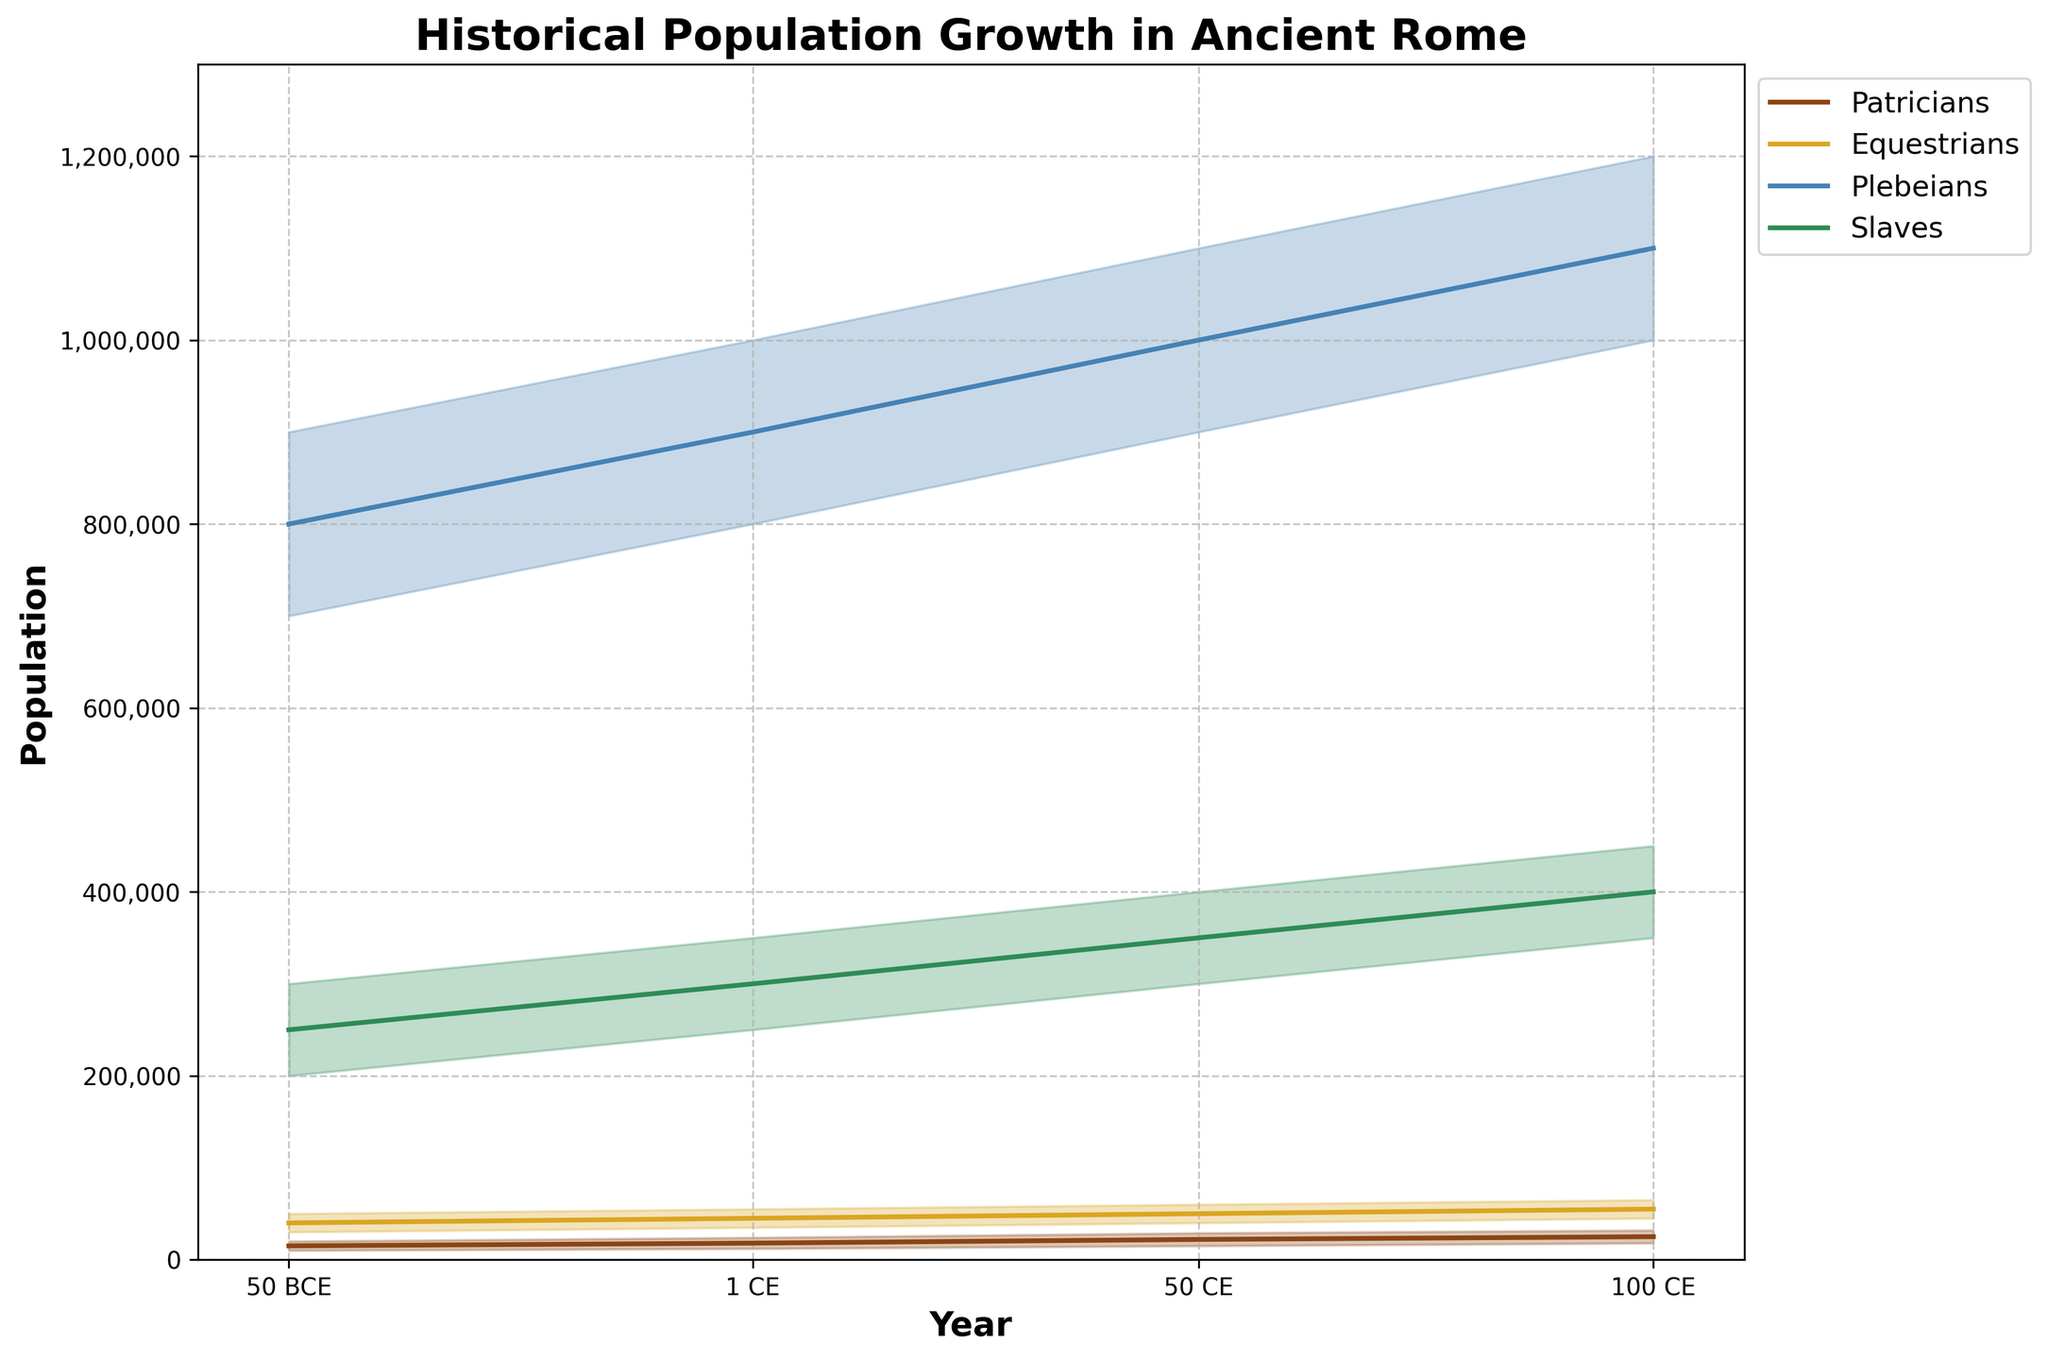What is the title of the chart? The title is located at the top of the chart. It reads "Historical Population Growth in Ancient Rome".
Answer: Historical Population Growth in Ancient Rome What does the x-axis represent? The x-axis is labelled "Year" and includes four points: 50 BCE, 1 CE, 50 CE, and 100 CE.
Answer: Year What does the y-axis represent? The y-axis is labelled "Population" and shows the number of people in each class over time.
Answer: Population Which social class had the largest population in 50 BCE? By comparing the plotted lines and shaded areas for all classes in 50 BCE, the Plebeians had the largest median population, with around 800,000 people.
Answer: Plebeians What was the median population of the Equestrians in 1 CE? By referring to the Equestrians' line plot at the year 1 CE, located slightly to the right of the middle, the median population is approximately 45,000.
Answer: 45,000 By how much did the median population of Patricians increase from 50 BCE to 100 CE? Look at the Patricians' median line in both 50 BCE (15,000) and 100 CE (25,000). Subtract the earlier value from the later value: 25,000 - 15,000 = 10,000.
Answer: 10,000 Which two classes show a significant increase in their median population from 50 BCE to 100 CE? By comparing the median lines across the years, the Plebeians and the Slaves show significant increases in median population. The Plebeians increased from 800,000 to 1,100,000, and the Slaves from 250,000 to 400,000.
Answer: Plebeians, Slaves Between which years did the Equestrians' population show the highest growth? Compare the slope of the Equestrians' median line. The line segment from 1 CE (45,000) to 50 CE (50,000) shows the highest growth.
Answer: 1 CE to 50 CE In which year did the median population of all classes combined reach approximately 1.6 million? Sum the median populations for all classes in each year and compare. In 50 CE, the combined median populations are approximately: Patricians 22,000 + Equestrians 50,000 + Plebeians 1,000,000 + Slaves 350,000 = 1,422,000. This is closest to 1.6 million.
Answer: 50 CE Which social class has the smallest range of the population estimates throughout the time period? Compare the widths of the shaded areas (ranges) for all the classes over time. The Equestrians have the smallest range of estimates throughout the time period.
Answer: Equestrians 